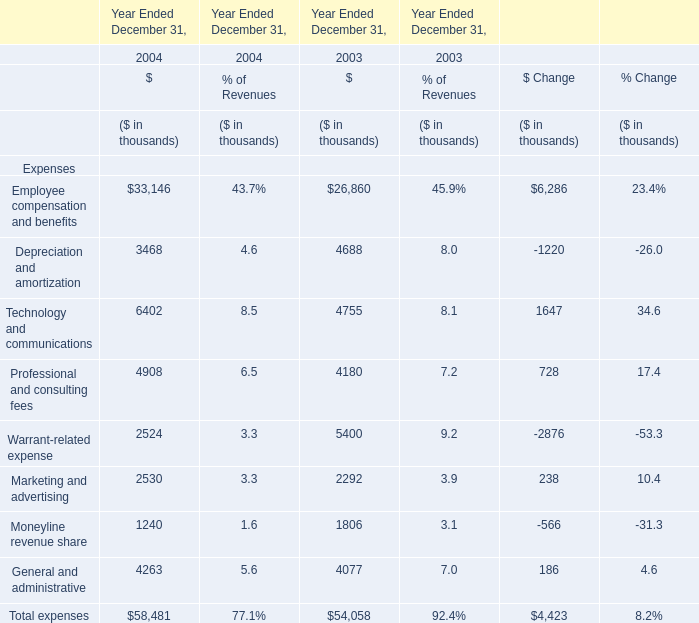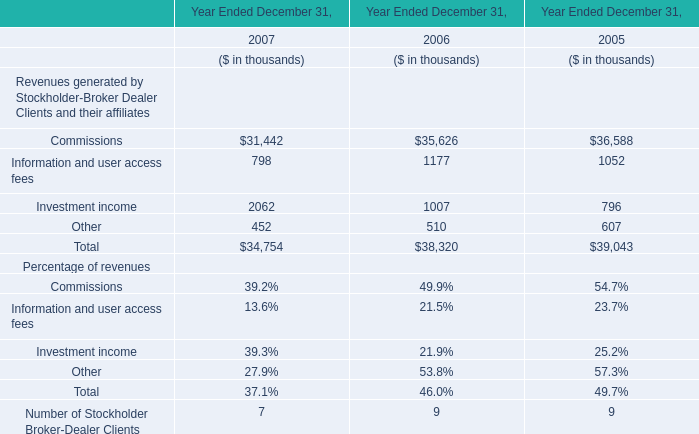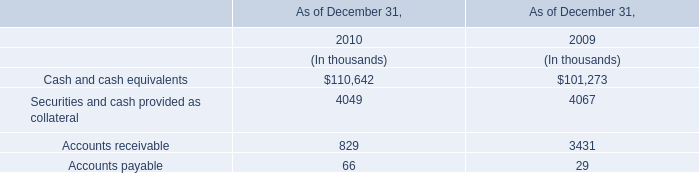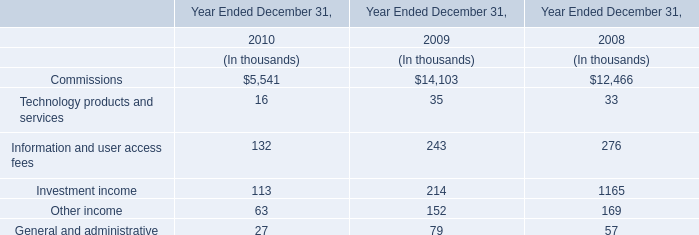What is the ratio of Technology and communications to the total in 2003? (in %) 
Computations: (4755 / 54058)
Answer: 0.08796. 